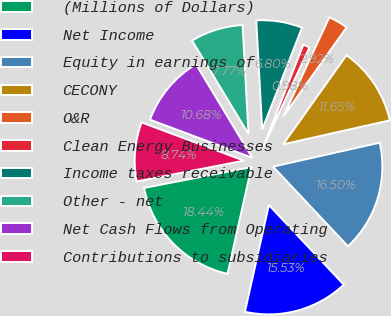Convert chart to OTSL. <chart><loc_0><loc_0><loc_500><loc_500><pie_chart><fcel>(Millions of Dollars)<fcel>Net Income<fcel>Equity in earnings of<fcel>CECONY<fcel>O&R<fcel>Clean Energy Businesses<fcel>Income taxes receivable<fcel>Other - net<fcel>Net Cash Flows from Operating<fcel>Contributions to subsidiaries<nl><fcel>18.44%<fcel>15.53%<fcel>16.5%<fcel>11.65%<fcel>2.92%<fcel>0.98%<fcel>6.8%<fcel>7.77%<fcel>10.68%<fcel>8.74%<nl></chart> 